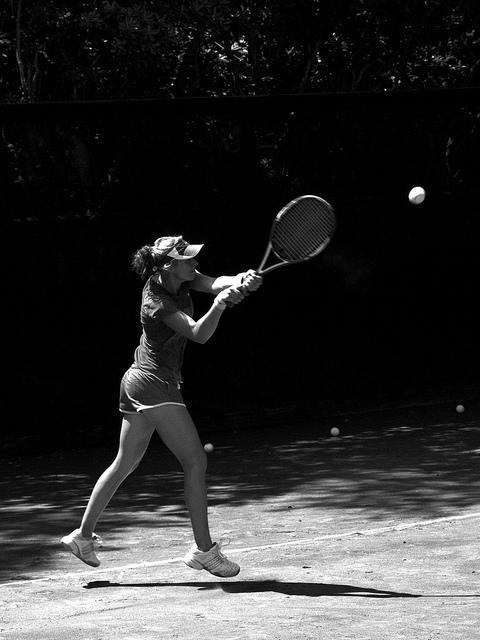How many athletes are featured in this picture?
Give a very brief answer. 1. 